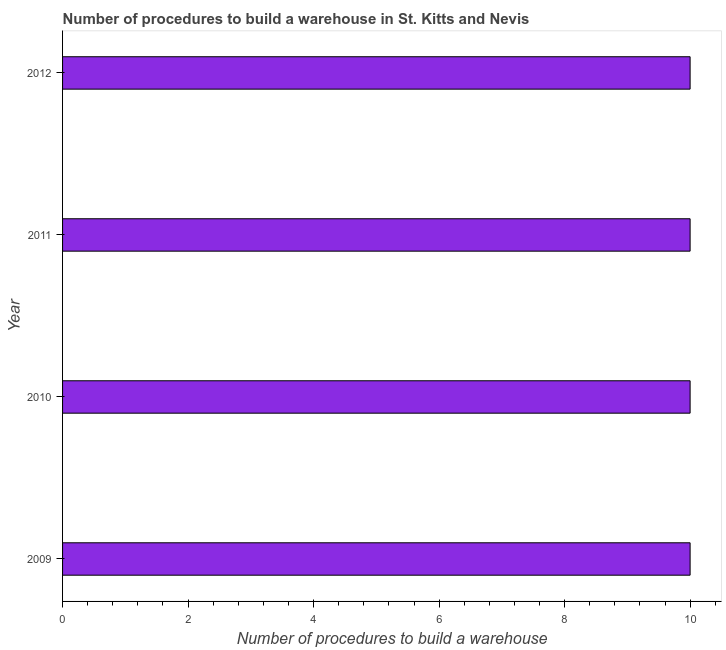Does the graph contain any zero values?
Keep it short and to the point. No. What is the title of the graph?
Provide a succinct answer. Number of procedures to build a warehouse in St. Kitts and Nevis. What is the label or title of the X-axis?
Offer a terse response. Number of procedures to build a warehouse. What is the number of procedures to build a warehouse in 2010?
Ensure brevity in your answer.  10. Across all years, what is the maximum number of procedures to build a warehouse?
Offer a very short reply. 10. Across all years, what is the minimum number of procedures to build a warehouse?
Offer a very short reply. 10. In which year was the number of procedures to build a warehouse maximum?
Keep it short and to the point. 2009. What is the average number of procedures to build a warehouse per year?
Your response must be concise. 10. What is the ratio of the number of procedures to build a warehouse in 2009 to that in 2010?
Offer a very short reply. 1. Is the difference between the number of procedures to build a warehouse in 2011 and 2012 greater than the difference between any two years?
Keep it short and to the point. Yes. In how many years, is the number of procedures to build a warehouse greater than the average number of procedures to build a warehouse taken over all years?
Make the answer very short. 0. How many bars are there?
Keep it short and to the point. 4. What is the Number of procedures to build a warehouse in 2010?
Your response must be concise. 10. What is the difference between the Number of procedures to build a warehouse in 2009 and 2012?
Offer a very short reply. 0. What is the difference between the Number of procedures to build a warehouse in 2010 and 2011?
Your answer should be very brief. 0. What is the difference between the Number of procedures to build a warehouse in 2010 and 2012?
Provide a succinct answer. 0. What is the difference between the Number of procedures to build a warehouse in 2011 and 2012?
Provide a succinct answer. 0. What is the ratio of the Number of procedures to build a warehouse in 2009 to that in 2011?
Ensure brevity in your answer.  1. What is the ratio of the Number of procedures to build a warehouse in 2009 to that in 2012?
Give a very brief answer. 1. 